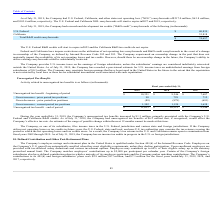According to Guidewire Software's financial document, What was the increase in unrecognized tax benefits in 2019? According to the financial document, $1.3 million. The relevant text states: "e Company’s unrecognized tax benefits increased by $1.3 million, primarily associated with the Company’s U.S...." Also, What was the Gross increases - prior period tax positions in 2019, 2018 and 2017 respectively? The document contains multiple relevant values: 98, 729, 712 (in thousands). From the document: "oss increases - prior period tax positions 98 729 712 Gross increases - prior period tax positions 98 729 712 Gross increases - prior period tax posit..." Also, What was the Gross decreases - prior period tax positions in 2019? According to the financial document, (88) (in thousands). The relevant text states: "Gross decreases - prior period tax positions (88) (878) (691)..." Additionally, In which year was Unrecognized tax benefit - end of period less than 10,000 thousands? According to the financial document, 2017. The relevant text states: "2019 2018 2017..." Also, can you calculate: What was the average Unrecognized tax benefit - beginning of period for 2017-2019? To answer this question, I need to perform calculations using the financial data. The calculation is: (11,633 + 10,321 + 9,346) / 3, which equals 10433.33 (in thousands). This is based on the information: "Unrecognized tax benefit - beginning of period $ 10,321 $ 9,346 $ 7,687 Unrecognized tax benefit - end of period $ 11,633 $ 10,321 $ 9,346 ized tax benefit - beginning of period $ 10,321 $ 9,346 $ 7,6..." The key data points involved are: 10,321, 11,633, 9,346. Also, can you calculate: What was the change in the Gross increases - prior period tax positions from 2018 to 2019? Based on the calculation: 98 - 729, the result is -631 (in thousands). This is based on the information: "Gross increases - prior period tax positions 98 729 712 Gross increases - prior period tax positions 98 729 712..." The key data points involved are: 729, 98. 